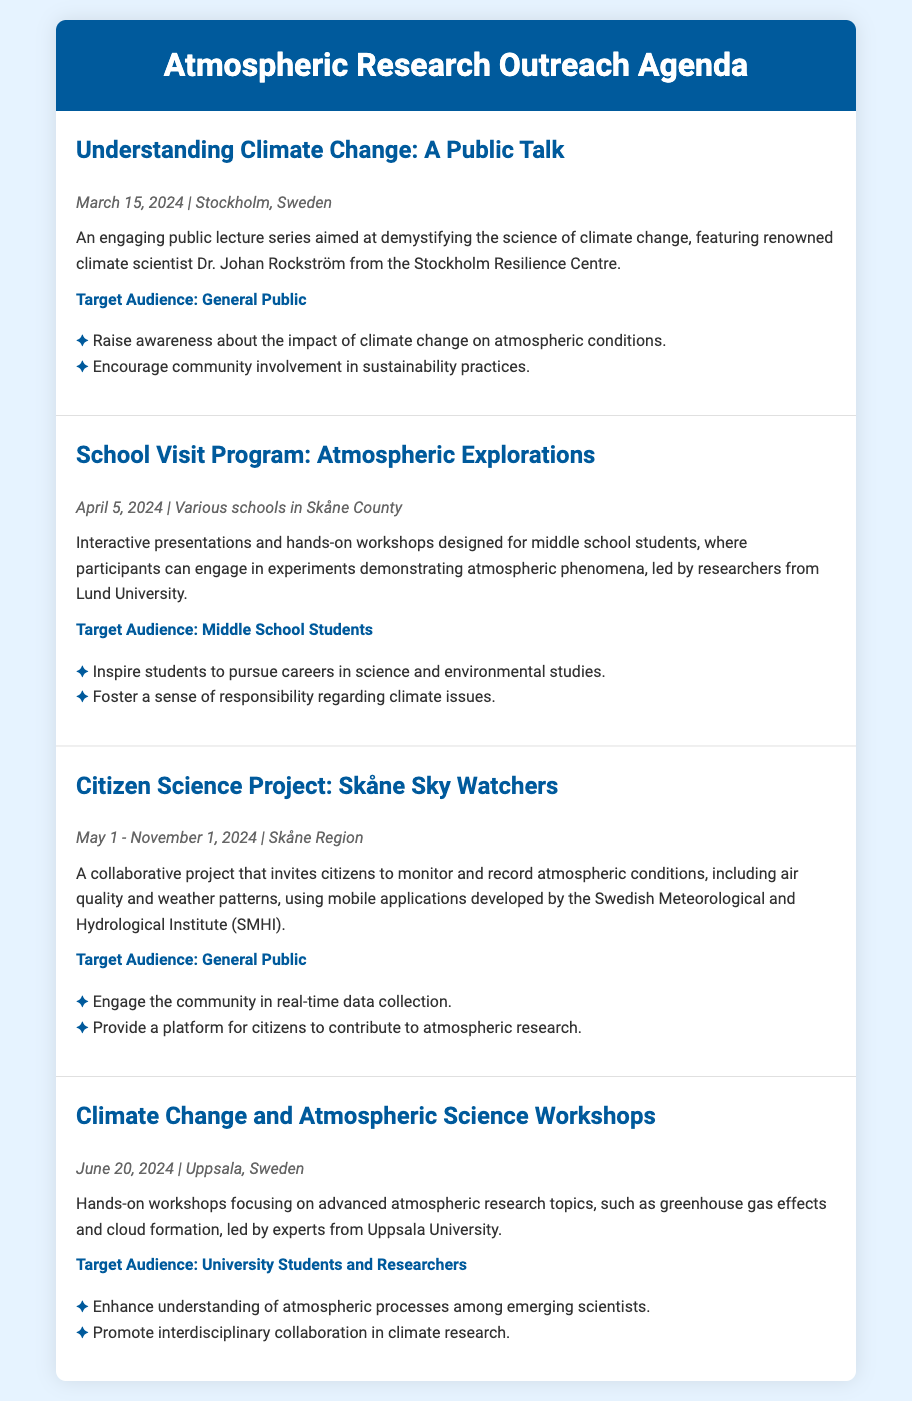What is the title of the first activity? The title of the first activity is presented prominently at the beginning of the activity section.
Answer: Understanding Climate Change: A Public Talk Who is the speaker for the public talk? The speaker's name is included in the description of the first activity.
Answer: Dr. Johan Rockström When does the Citizen Science Project start? The start date is outlined in the date-location section of the Citizen Science Project activity.
Answer: May 1, 2024 What is the target audience for the School Visit Program? The target audience is explicitly stated in the respective activity description.
Answer: Middle School Students How many goals are outlined for the Climate Change and Atmospheric Science Workshops? The number of goals can be counted from the list provided in this specific activity.
Answer: Two What city will the Climate Change workshops take place in? The city is mentioned in the date-location section of the workshop activity.
Answer: Uppsala What kind of project is "Skåne Sky Watchers"? The type of project is indicated in the description of this particular activity.
Answer: Citizen Science Project Which institution is leading the School Visit Program? The leading institution is mentioned in the description of the School Visit Program.
Answer: Lund University 